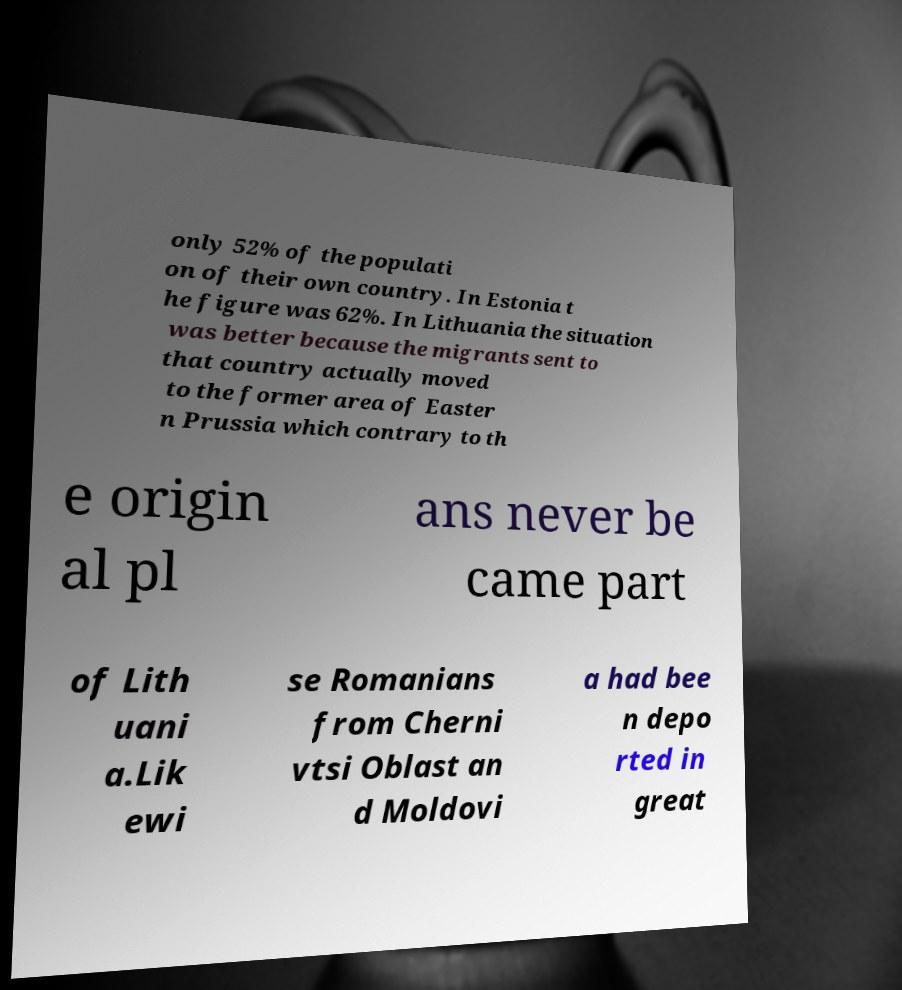Can you read and provide the text displayed in the image?This photo seems to have some interesting text. Can you extract and type it out for me? only 52% of the populati on of their own country. In Estonia t he figure was 62%. In Lithuania the situation was better because the migrants sent to that country actually moved to the former area of Easter n Prussia which contrary to th e origin al pl ans never be came part of Lith uani a.Lik ewi se Romanians from Cherni vtsi Oblast an d Moldovi a had bee n depo rted in great 